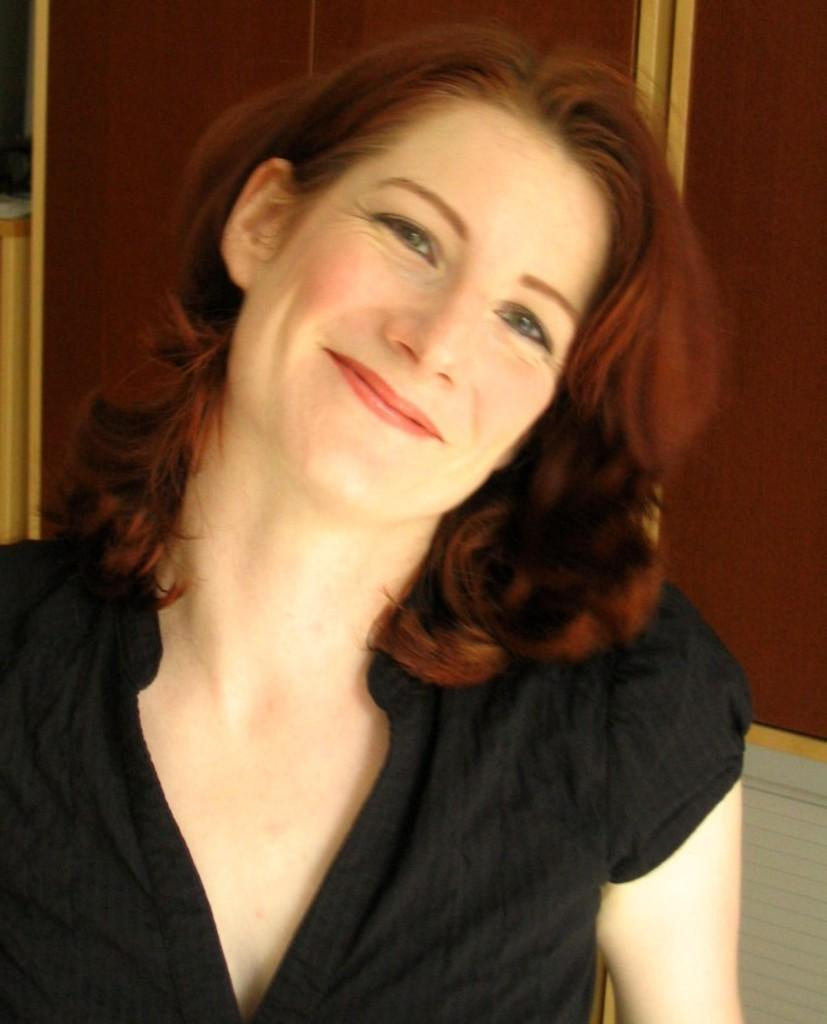Who is the main subject in the image? There is a lady in the image. What is the lady wearing? The lady is wearing a black t-shirt. What expression does the lady have? The lady is smiling. What can be seen in the background of the image? There is a wall in the background of the image. What type of offer is the lady making in the image? There is no offer being made in the image; the lady is simply smiling. How many feet can be seen in the image? There is no foot visible in the image; it only shows the lady from the waist up. 